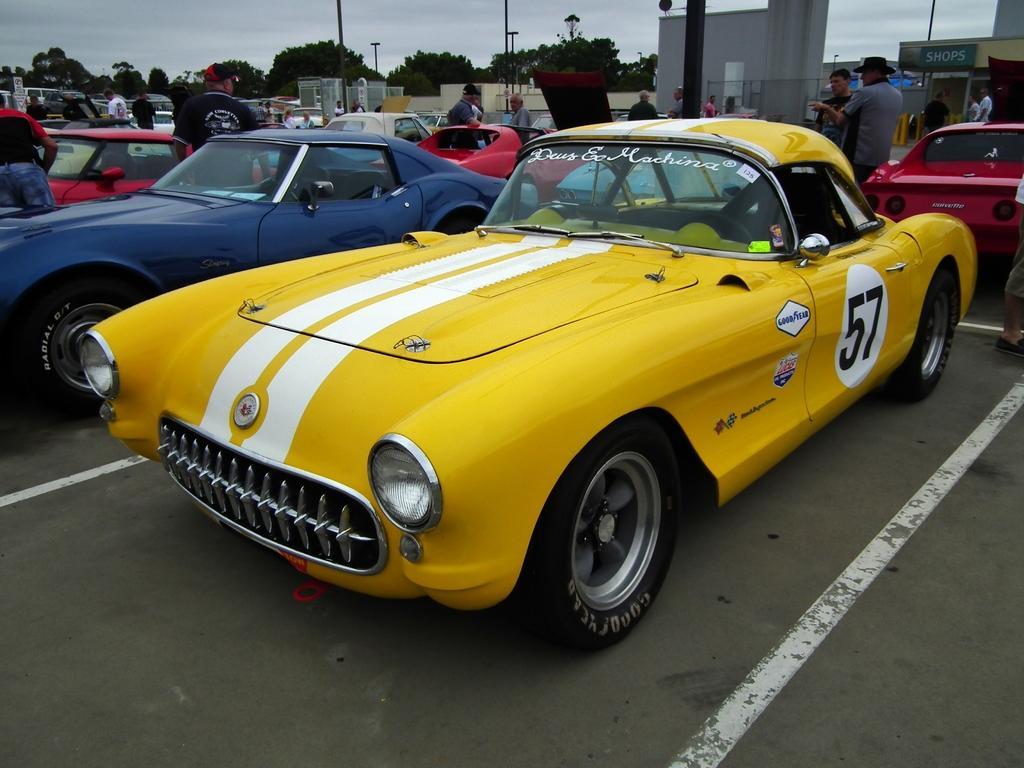Describe this image in one or two sentences. In this image we can see cars and people standing on the road. Here we can see poles, trees, board, walls, and other objects. In the background there is sky. 